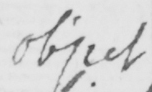What text is written in this handwritten line? object 